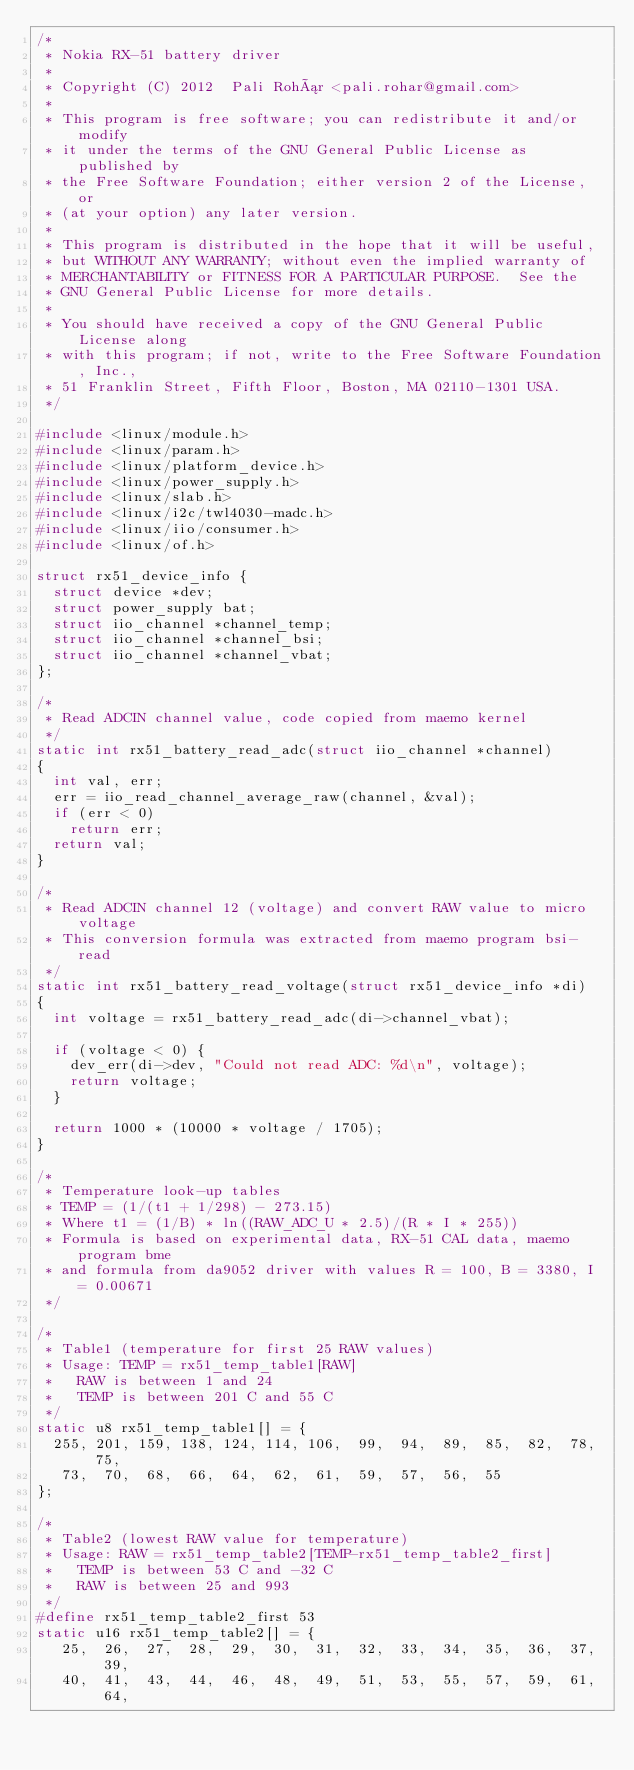Convert code to text. <code><loc_0><loc_0><loc_500><loc_500><_C_>/*
 * Nokia RX-51 battery driver
 *
 * Copyright (C) 2012  Pali Rohár <pali.rohar@gmail.com>
 *
 * This program is free software; you can redistribute it and/or modify
 * it under the terms of the GNU General Public License as published by
 * the Free Software Foundation; either version 2 of the License, or
 * (at your option) any later version.
 *
 * This program is distributed in the hope that it will be useful,
 * but WITHOUT ANY WARRANTY; without even the implied warranty of
 * MERCHANTABILITY or FITNESS FOR A PARTICULAR PURPOSE.  See the
 * GNU General Public License for more details.
 *
 * You should have received a copy of the GNU General Public License along
 * with this program; if not, write to the Free Software Foundation, Inc.,
 * 51 Franklin Street, Fifth Floor, Boston, MA 02110-1301 USA.
 */

#include <linux/module.h>
#include <linux/param.h>
#include <linux/platform_device.h>
#include <linux/power_supply.h>
#include <linux/slab.h>
#include <linux/i2c/twl4030-madc.h>
#include <linux/iio/consumer.h>
#include <linux/of.h>

struct rx51_device_info {
	struct device *dev;
	struct power_supply bat;
	struct iio_channel *channel_temp;
	struct iio_channel *channel_bsi;
	struct iio_channel *channel_vbat;
};

/*
 * Read ADCIN channel value, code copied from maemo kernel
 */
static int rx51_battery_read_adc(struct iio_channel *channel)
{
	int val, err;
	err = iio_read_channel_average_raw(channel, &val);
	if (err < 0)
		return err;
	return val;
}

/*
 * Read ADCIN channel 12 (voltage) and convert RAW value to micro voltage
 * This conversion formula was extracted from maemo program bsi-read
 */
static int rx51_battery_read_voltage(struct rx51_device_info *di)
{
	int voltage = rx51_battery_read_adc(di->channel_vbat);

	if (voltage < 0) {
		dev_err(di->dev, "Could not read ADC: %d\n", voltage);
		return voltage;
	}

	return 1000 * (10000 * voltage / 1705);
}

/*
 * Temperature look-up tables
 * TEMP = (1/(t1 + 1/298) - 273.15)
 * Where t1 = (1/B) * ln((RAW_ADC_U * 2.5)/(R * I * 255))
 * Formula is based on experimental data, RX-51 CAL data, maemo program bme
 * and formula from da9052 driver with values R = 100, B = 3380, I = 0.00671
 */

/*
 * Table1 (temperature for first 25 RAW values)
 * Usage: TEMP = rx51_temp_table1[RAW]
 *   RAW is between 1 and 24
 *   TEMP is between 201 C and 55 C
 */
static u8 rx51_temp_table1[] = {
	255, 201, 159, 138, 124, 114, 106,  99,  94,  89,  85,  82,  78,  75,
	 73,  70,  68,  66,  64,  62,  61,  59,  57,  56,  55
};

/*
 * Table2 (lowest RAW value for temperature)
 * Usage: RAW = rx51_temp_table2[TEMP-rx51_temp_table2_first]
 *   TEMP is between 53 C and -32 C
 *   RAW is between 25 and 993
 */
#define rx51_temp_table2_first 53
static u16 rx51_temp_table2[] = {
	 25,  26,  27,  28,  29,  30,  31,  32,  33,  34,  35,  36,  37,  39,
	 40,  41,  43,  44,  46,  48,  49,  51,  53,  55,  57,  59,  61,  64,</code> 